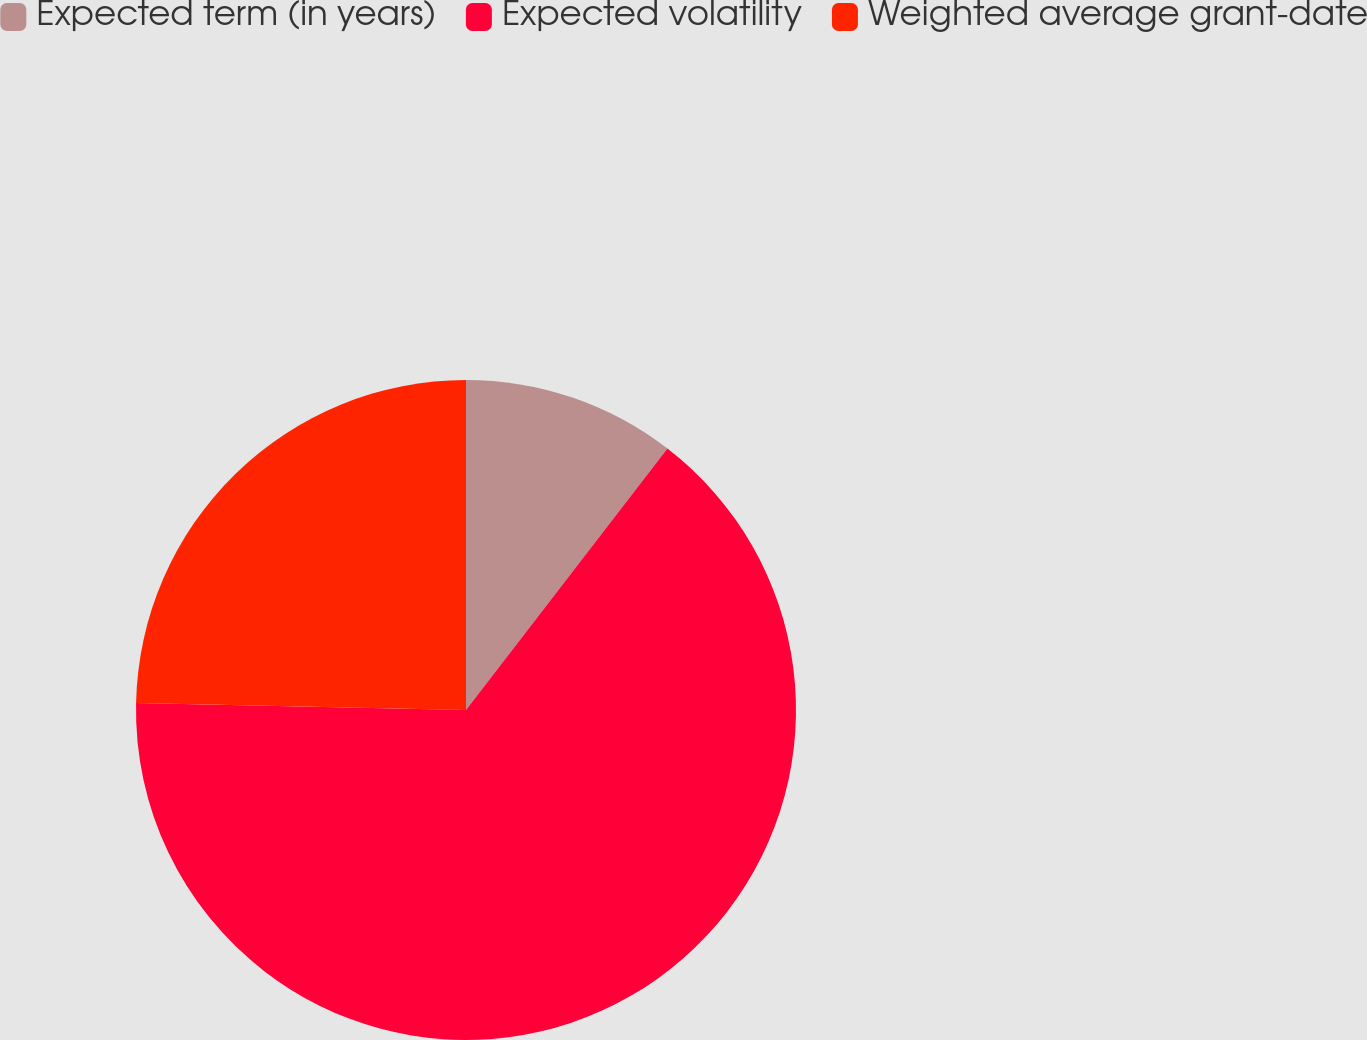Convert chart. <chart><loc_0><loc_0><loc_500><loc_500><pie_chart><fcel>Expected term (in years)<fcel>Expected volatility<fcel>Weighted average grant-date<nl><fcel>10.45%<fcel>64.89%<fcel>24.67%<nl></chart> 